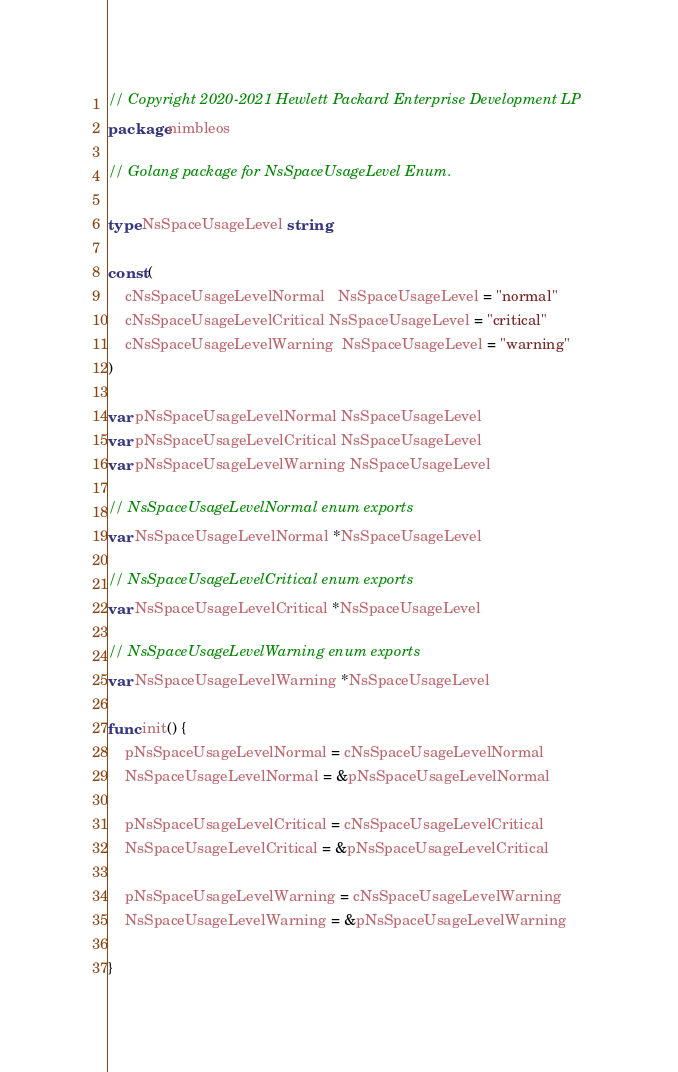Convert code to text. <code><loc_0><loc_0><loc_500><loc_500><_Go_>// Copyright 2020-2021 Hewlett Packard Enterprise Development LP
package nimbleos

// Golang package for NsSpaceUsageLevel Enum.

type NsSpaceUsageLevel string

const (
	cNsSpaceUsageLevelNormal   NsSpaceUsageLevel = "normal"
	cNsSpaceUsageLevelCritical NsSpaceUsageLevel = "critical"
	cNsSpaceUsageLevelWarning  NsSpaceUsageLevel = "warning"
)

var pNsSpaceUsageLevelNormal NsSpaceUsageLevel
var pNsSpaceUsageLevelCritical NsSpaceUsageLevel
var pNsSpaceUsageLevelWarning NsSpaceUsageLevel

// NsSpaceUsageLevelNormal enum exports
var NsSpaceUsageLevelNormal *NsSpaceUsageLevel

// NsSpaceUsageLevelCritical enum exports
var NsSpaceUsageLevelCritical *NsSpaceUsageLevel

// NsSpaceUsageLevelWarning enum exports
var NsSpaceUsageLevelWarning *NsSpaceUsageLevel

func init() {
	pNsSpaceUsageLevelNormal = cNsSpaceUsageLevelNormal
	NsSpaceUsageLevelNormal = &pNsSpaceUsageLevelNormal

	pNsSpaceUsageLevelCritical = cNsSpaceUsageLevelCritical
	NsSpaceUsageLevelCritical = &pNsSpaceUsageLevelCritical

	pNsSpaceUsageLevelWarning = cNsSpaceUsageLevelWarning
	NsSpaceUsageLevelWarning = &pNsSpaceUsageLevelWarning

}
</code> 